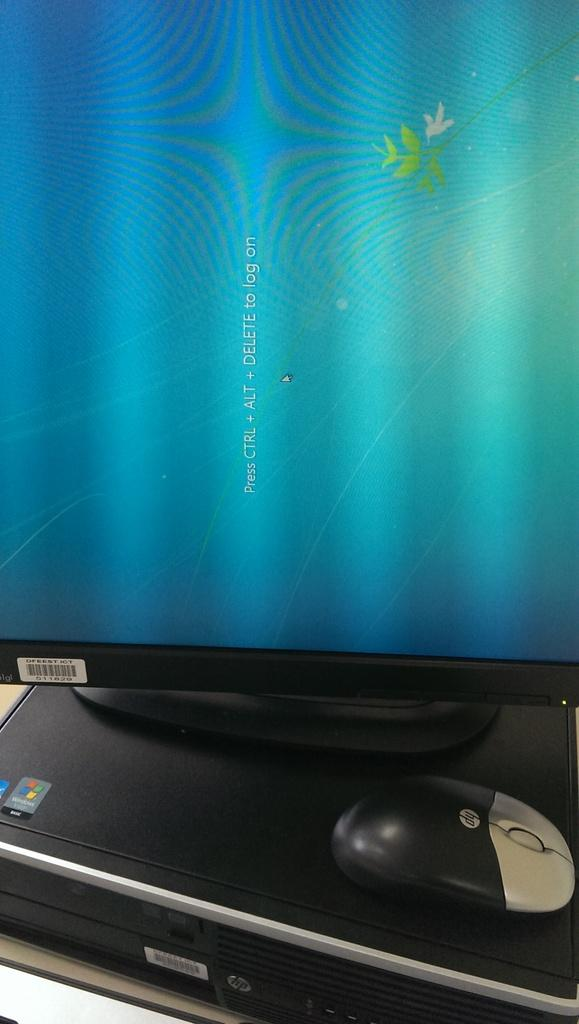What type of electronic device is visible in the image? There is a CPU in the image. What is the CPU placed on? The CPU is on an object. What other computer peripheral can be seen in the image? There is a mouse in the image. What is used to display visual output from the CPU? There is a monitor in the image. How does the snow affect the father's ability to use the CPU in the image? There is no snow or father present in the image; it only features a CPU, a mouse, and a monitor. 